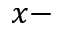Convert formula to latex. <formula><loc_0><loc_0><loc_500><loc_500>x -</formula> 